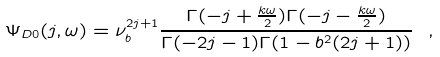Convert formula to latex. <formula><loc_0><loc_0><loc_500><loc_500>\Psi _ { D 0 } ( j , \omega ) = \nu _ { b } ^ { 2 j + 1 } \frac { \Gamma ( - j + \frac { k \omega } { 2 } ) \Gamma ( - j - \frac { k \omega } { 2 } ) } { \Gamma ( - 2 j - 1 ) \Gamma ( 1 - b ^ { 2 } ( 2 j + 1 ) ) } \ ,</formula> 